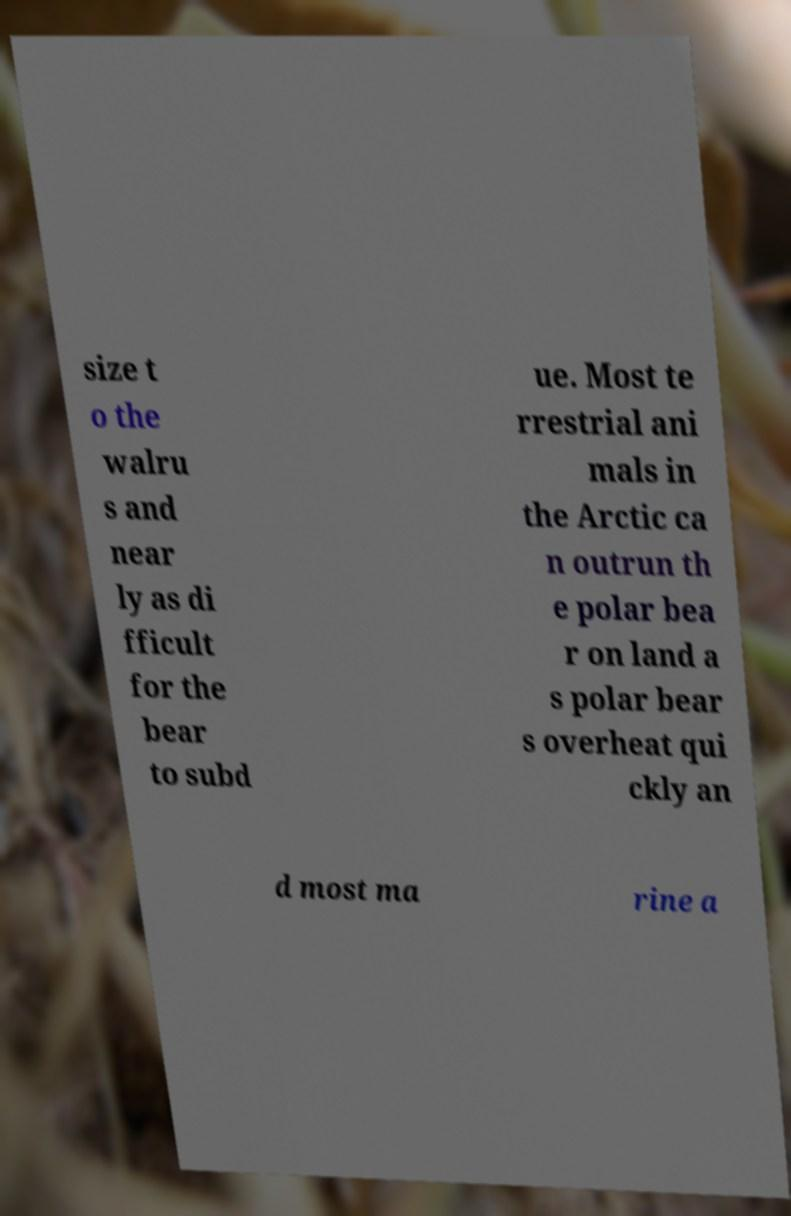There's text embedded in this image that I need extracted. Can you transcribe it verbatim? size t o the walru s and near ly as di fficult for the bear to subd ue. Most te rrestrial ani mals in the Arctic ca n outrun th e polar bea r on land a s polar bear s overheat qui ckly an d most ma rine a 